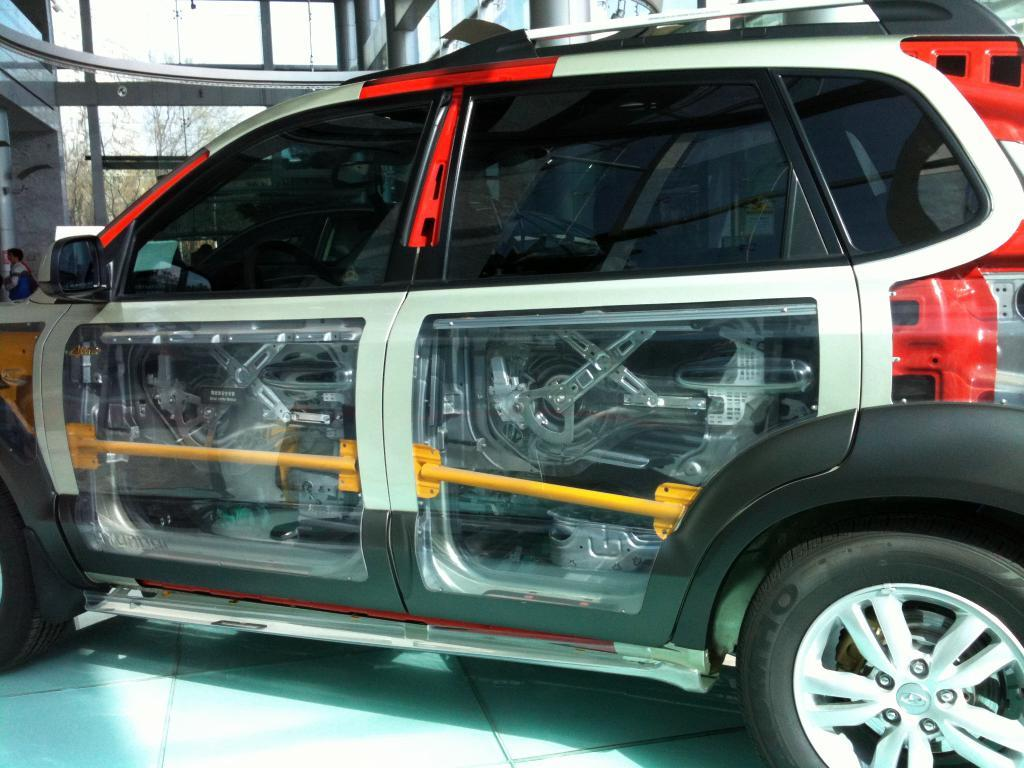What is parked in the image? There is a car parked in the image. What can be seen through the windows of the building in the image? Trees and the sky are visible through the building's windows. How does the sky appear in the image? The sky appears to be cloudy in the image. What degree does the elbow of the person in the image have? There is no person present in the image, so it is not possible to determine the degree of their elbow. 